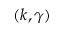Convert formula to latex. <formula><loc_0><loc_0><loc_500><loc_500>( k , \gamma )</formula> 